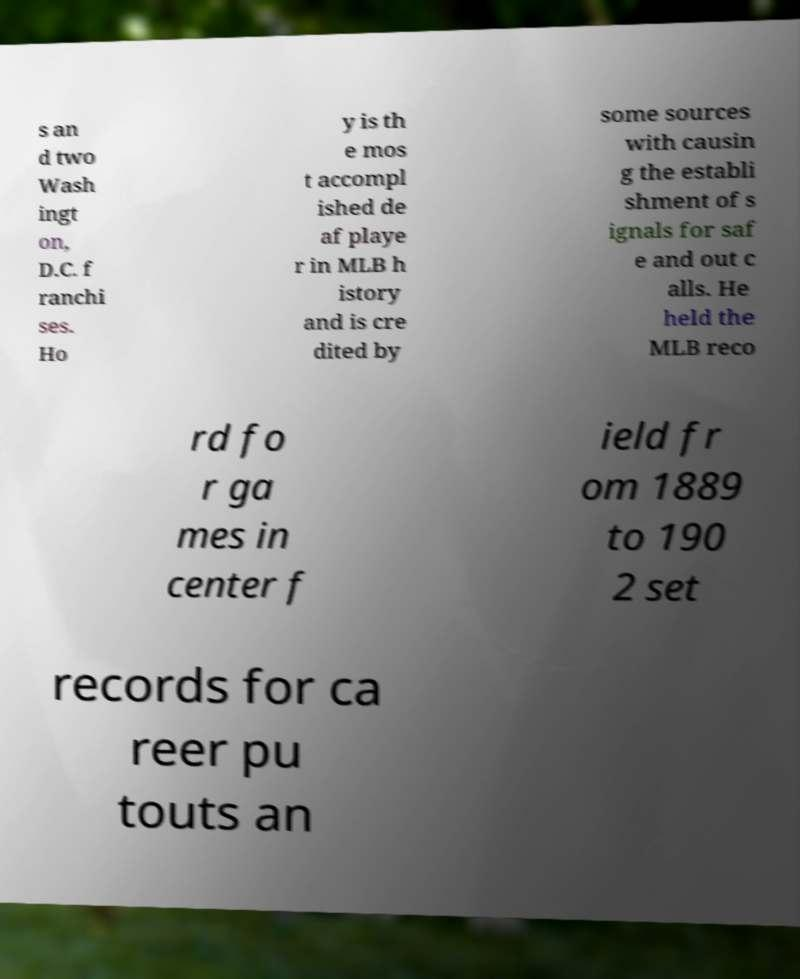For documentation purposes, I need the text within this image transcribed. Could you provide that? s an d two Wash ingt on, D.C. f ranchi ses. Ho y is th e mos t accompl ished de af playe r in MLB h istory and is cre dited by some sources with causin g the establi shment of s ignals for saf e and out c alls. He held the MLB reco rd fo r ga mes in center f ield fr om 1889 to 190 2 set records for ca reer pu touts an 